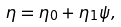<formula> <loc_0><loc_0><loc_500><loc_500>\eta = \eta _ { 0 } + \eta _ { 1 } \psi ,</formula> 